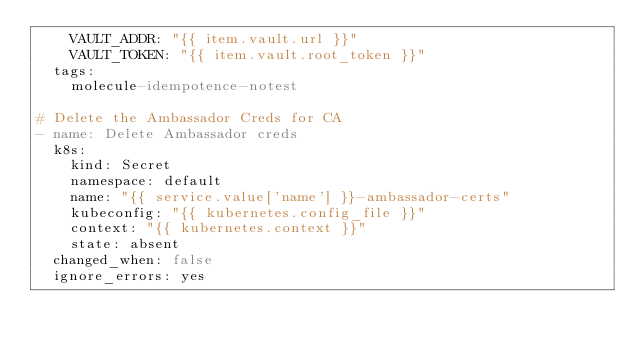<code> <loc_0><loc_0><loc_500><loc_500><_YAML_>    VAULT_ADDR: "{{ item.vault.url }}"
    VAULT_TOKEN: "{{ item.vault.root_token }}"
  tags:
    molecule-idempotence-notest

# Delete the Ambassador Creds for CA
- name: Delete Ambassador creds
  k8s:
    kind: Secret
    namespace: default
    name: "{{ service.value['name'] }}-ambassador-certs"
    kubeconfig: "{{ kubernetes.config_file }}"
    context: "{{ kubernetes.context }}"
    state: absent
  changed_when: false
  ignore_errors: yes
</code> 